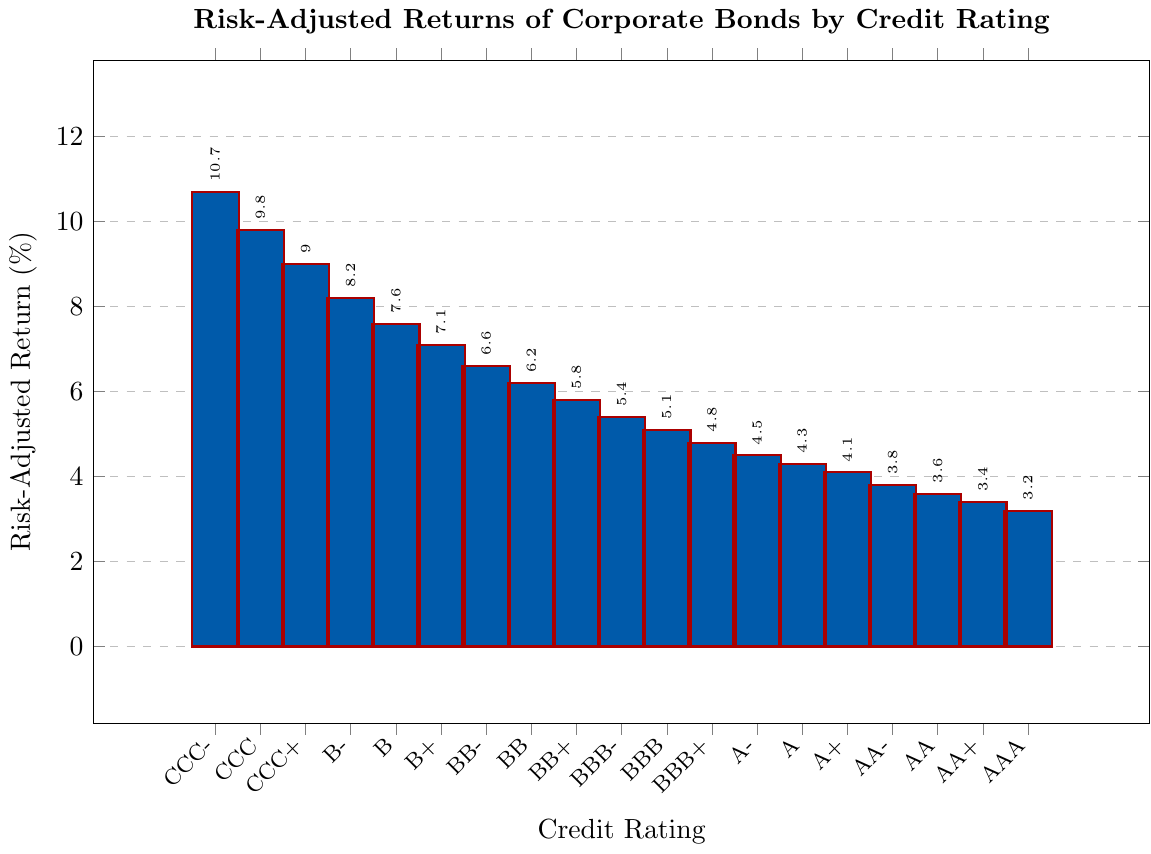What is the average risk-adjusted return for investment-grade corporate bonds (AAA to BBB-) compared to non-investment-grade bonds (BB+ to CCC-)? To find the average for investment-grade bonds (AAA to BBB-), sum their returns and divide by the number of ratings: (3.2 + 3.4 + 3.6 + 3.8 + 4.1 + 4.3 + 4.5 + 4.8 + 5.1 + 5.4) / 10 = 42.2 / 10 = 4.22%. For non-investment-grade bonds (BB+ to CCC-), sum their returns and divide by the number of ratings: (5.8 + 6.2 + 6.6 + 7.1 + 7.6 + 8.2 + 9.0 + 9.8 + 10.7) / 9 = 61 / 9 ≈ 6.78%.
Answer: 4.22% vs 6.78% Which credit rating has the highest risk-adjusted return? The chart shows that CCC- has the highest bar reaching a return of 10.7%.
Answer: CCC- How much higher is the risk-adjusted return of CCC- compared to AAA? Subtract the risk-adjusted return of AAA from CCC-: 10.7 - 3.2 = 7.5%.
Answer: 7.5% What is the difference in risk-adjusted returns between BBB+ and BBB-? Subtract the return of BBB+ from BBB-: 5.4 - 4.8 = 0.6%.
Answer: 0.6% Which credit rating has a risk-adjusted return close to the average return of all ratings? First, find the average return: (3.2 + 3.4 + 3.6 + 3.8 + 4.1 + 4.3 + 4.5 + 4.8 + 5.1 + 5.4 + 5.8 + 6.2 + 6.6 + 7.1 + 7.6 + 8.2 + 9.0 + 9.8 + 10.7) / 19 = 6.2%. BB's return is exactly 6.2%, matching the overall average.
Answer: BB Are there any ratings with the same risk-adjusted return? The chart shows unique values for each credit rating, so no ratings have the same return.
Answer: No What trend can be observed in risk-adjusted returns as credit ratings worsen? Observing the bars, as the credit ratings move from AAA down to CCC-, there is an increasing trend in risk-adjusted returns.
Answer: Increasing trend Between AA- and A-, which has a higher risk-adjusted return and by how much? Subtract the return of AA- from A-: 4.5 - 3.8 = 0.7%. A- has a higher return by 0.7%.
Answer: A-, 0.7% What is the median risk-adjusted return of the corporate bonds presented? Arrange the returns in ascending order and find the middle value: (3.2, 3.4, 3.6, 3.8, 4.1, 4.3, 4.5, 4.8, 5.1, 5.4, 5.8, 6.2, 6.6, 7.1, 7.6, 8.2, 9.0, 9.8, 10.7). The median value is the 10th value, which is 5.4%.
Answer: 5.4% What can be inferred about the stability of returns based on the credit rating of bonds? Higher-rated bonds (e.g., AAA to A) show lower and presumably more stable returns, whereas lower-rated bonds (e.g., BB to CCC-) show higher but potentially more volatile returns.
Answer: Higher-rated more stable, lower-rated more volatile 